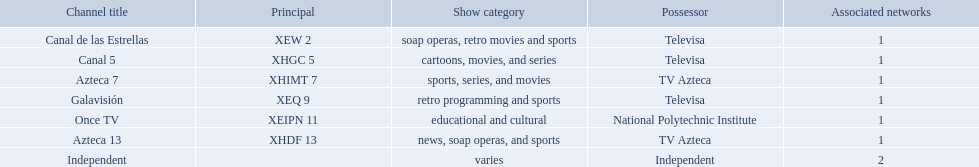What stations show sports? Soap operas, retro movies and sports, retro programming and sports, news, soap operas, and sports. What of these is not affiliated with televisa? Azteca 7. Which owner only owns one network? National Polytechnic Institute, Independent. Of those, what is the network name? Once TV, Independent. Of those, which programming type is educational and cultural? Once TV. Who are the owners of the stations listed here? Televisa, Televisa, TV Azteca, Televisa, National Polytechnic Institute, TV Azteca, Independent. What is the one station owned by national polytechnic institute? Once TV. 